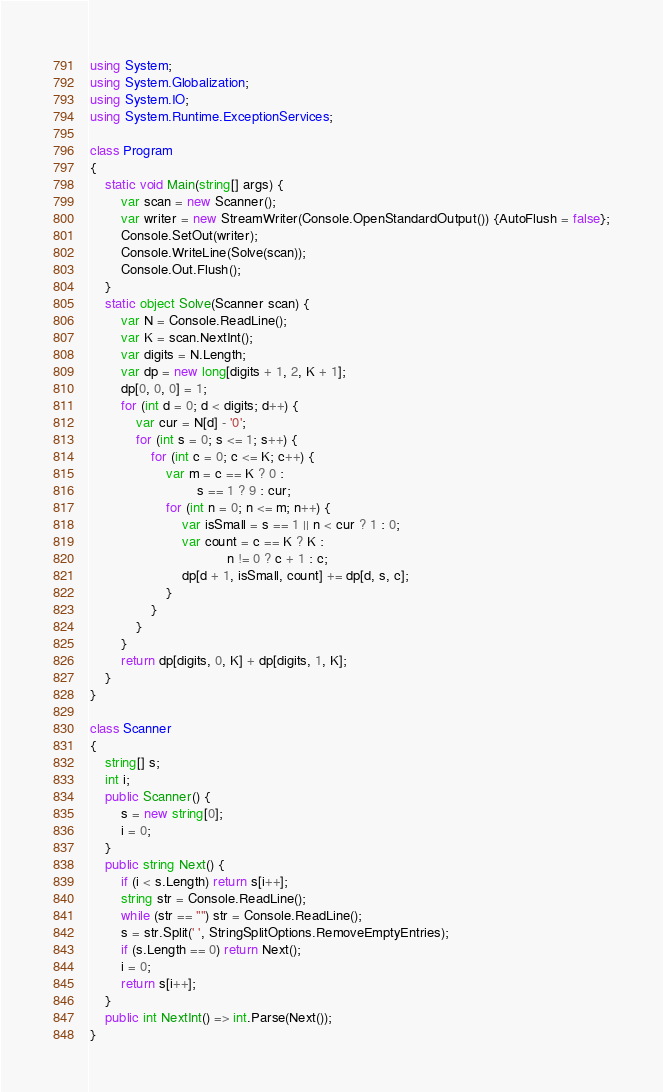Convert code to text. <code><loc_0><loc_0><loc_500><loc_500><_C#_>using System;
using System.Globalization;
using System.IO;
using System.Runtime.ExceptionServices;

class Program
{
    static void Main(string[] args) {
        var scan = new Scanner();
        var writer = new StreamWriter(Console.OpenStandardOutput()) {AutoFlush = false};
        Console.SetOut(writer);
        Console.WriteLine(Solve(scan));
        Console.Out.Flush();
    }
    static object Solve(Scanner scan) {
        var N = Console.ReadLine();
        var K = scan.NextInt();
        var digits = N.Length;
        var dp = new long[digits + 1, 2, K + 1];
        dp[0, 0, 0] = 1;
        for (int d = 0; d < digits; d++) {
            var cur = N[d] - '0';
            for (int s = 0; s <= 1; s++) {
                for (int c = 0; c <= K; c++) {
                    var m = c == K ? 0 :
                            s == 1 ? 9 : cur;
                    for (int n = 0; n <= m; n++) {
                        var isSmall = s == 1 || n < cur ? 1 : 0;
                        var count = c == K ? K : 
                                    n != 0 ? c + 1 : c;
                        dp[d + 1, isSmall, count] += dp[d, s, c];
                    }
                }
            }
        }
        return dp[digits, 0, K] + dp[digits, 1, K];
    }
}

class Scanner
{
    string[] s;
    int i;
    public Scanner() {
        s = new string[0];
        i = 0;
    }
    public string Next() {
        if (i < s.Length) return s[i++];
        string str = Console.ReadLine();
        while (str == "") str = Console.ReadLine();
        s = str.Split(' ', StringSplitOptions.RemoveEmptyEntries);
        if (s.Length == 0) return Next();
        i = 0;
        return s[i++];
    }
    public int NextInt() => int.Parse(Next());
}</code> 